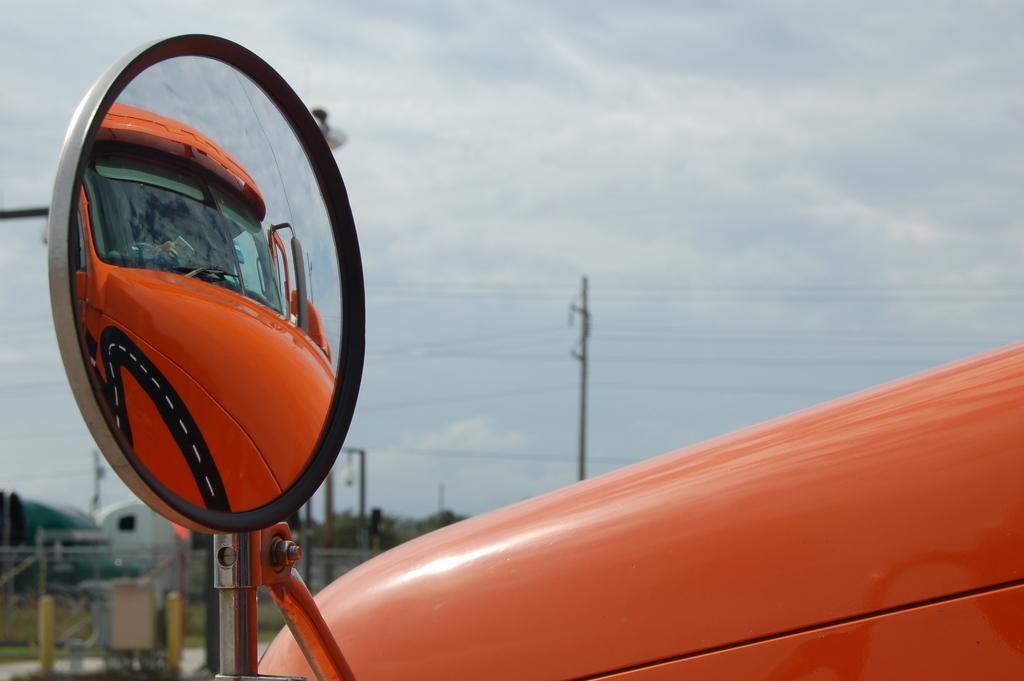Please provide a concise description of this image. Here I can see a mirror of a vehicle which is in red color. Inside the mirror I can see the reflection of this vehicle. In the background there are some poles and trees. On the top of the image I can see the sky. 